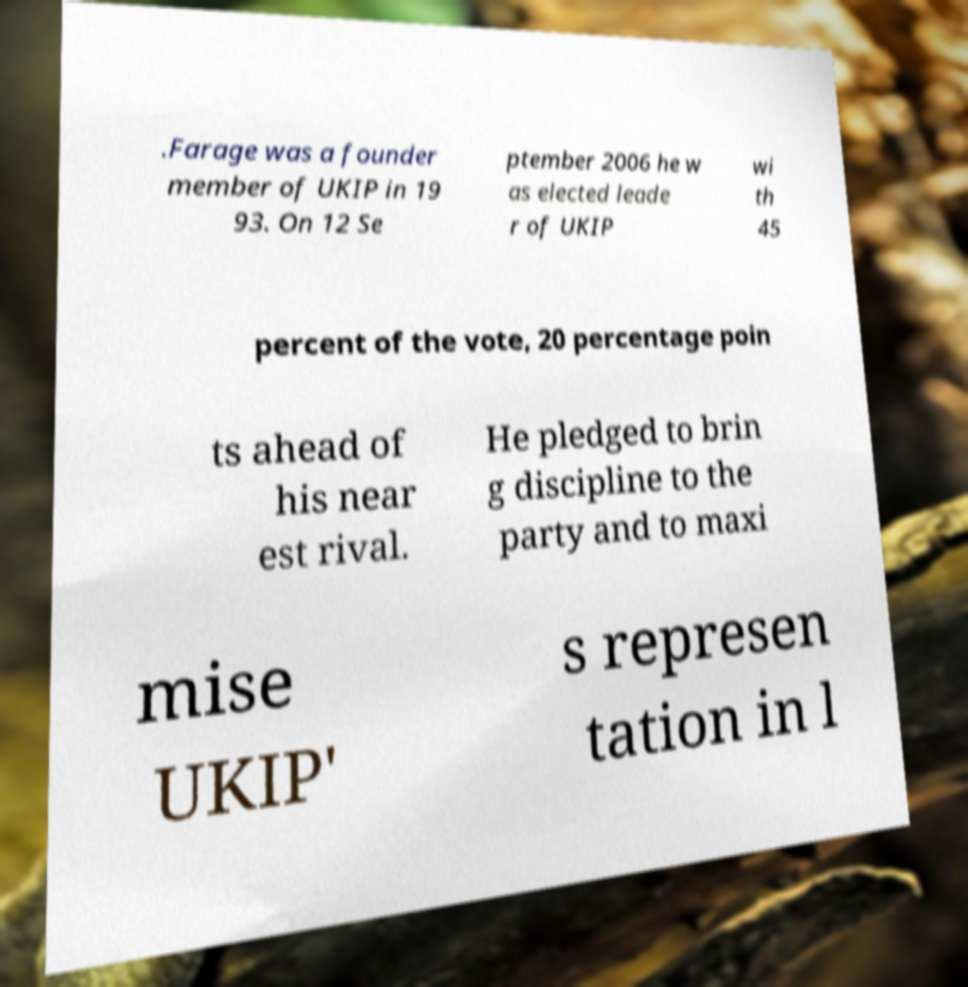What messages or text are displayed in this image? I need them in a readable, typed format. .Farage was a founder member of UKIP in 19 93. On 12 Se ptember 2006 he w as elected leade r of UKIP wi th 45 percent of the vote, 20 percentage poin ts ahead of his near est rival. He pledged to brin g discipline to the party and to maxi mise UKIP' s represen tation in l 